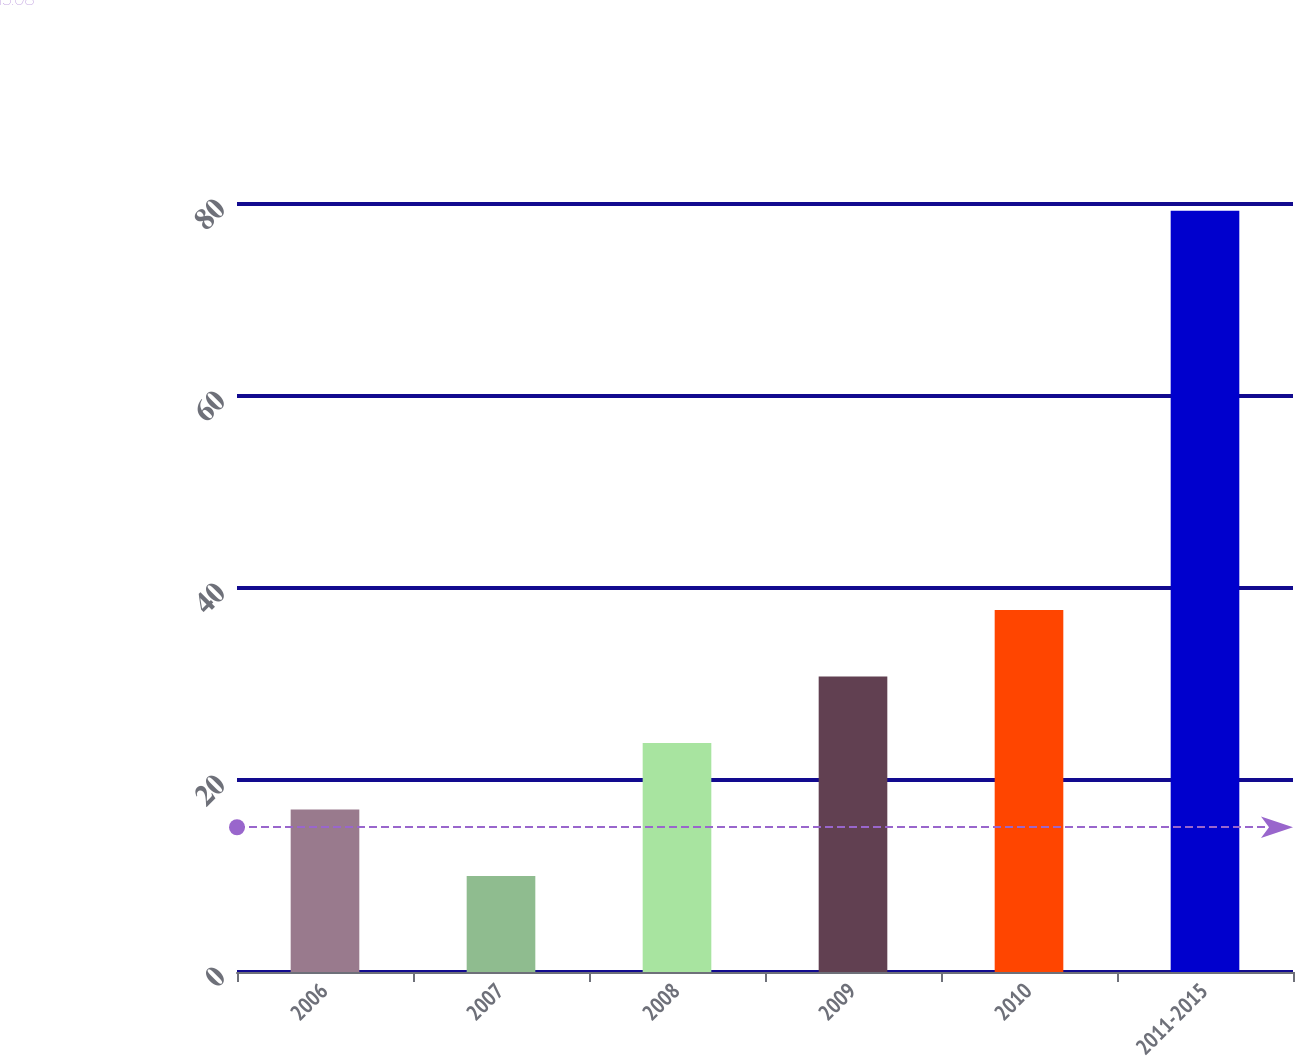Convert chart to OTSL. <chart><loc_0><loc_0><loc_500><loc_500><bar_chart><fcel>2006<fcel>2007<fcel>2008<fcel>2009<fcel>2010<fcel>2011-2015<nl><fcel>16.93<fcel>10<fcel>23.86<fcel>30.79<fcel>37.72<fcel>79.3<nl></chart> 